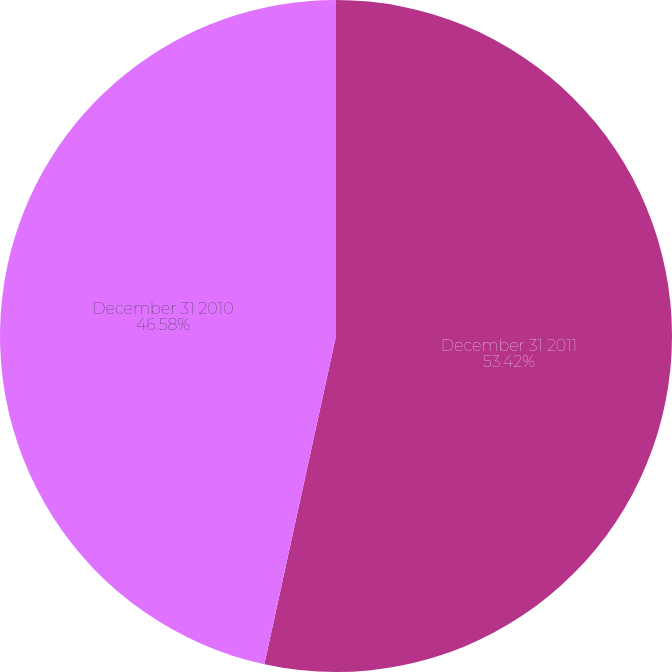Convert chart to OTSL. <chart><loc_0><loc_0><loc_500><loc_500><pie_chart><fcel>December 31 2011<fcel>December 31 2010<nl><fcel>53.42%<fcel>46.58%<nl></chart> 